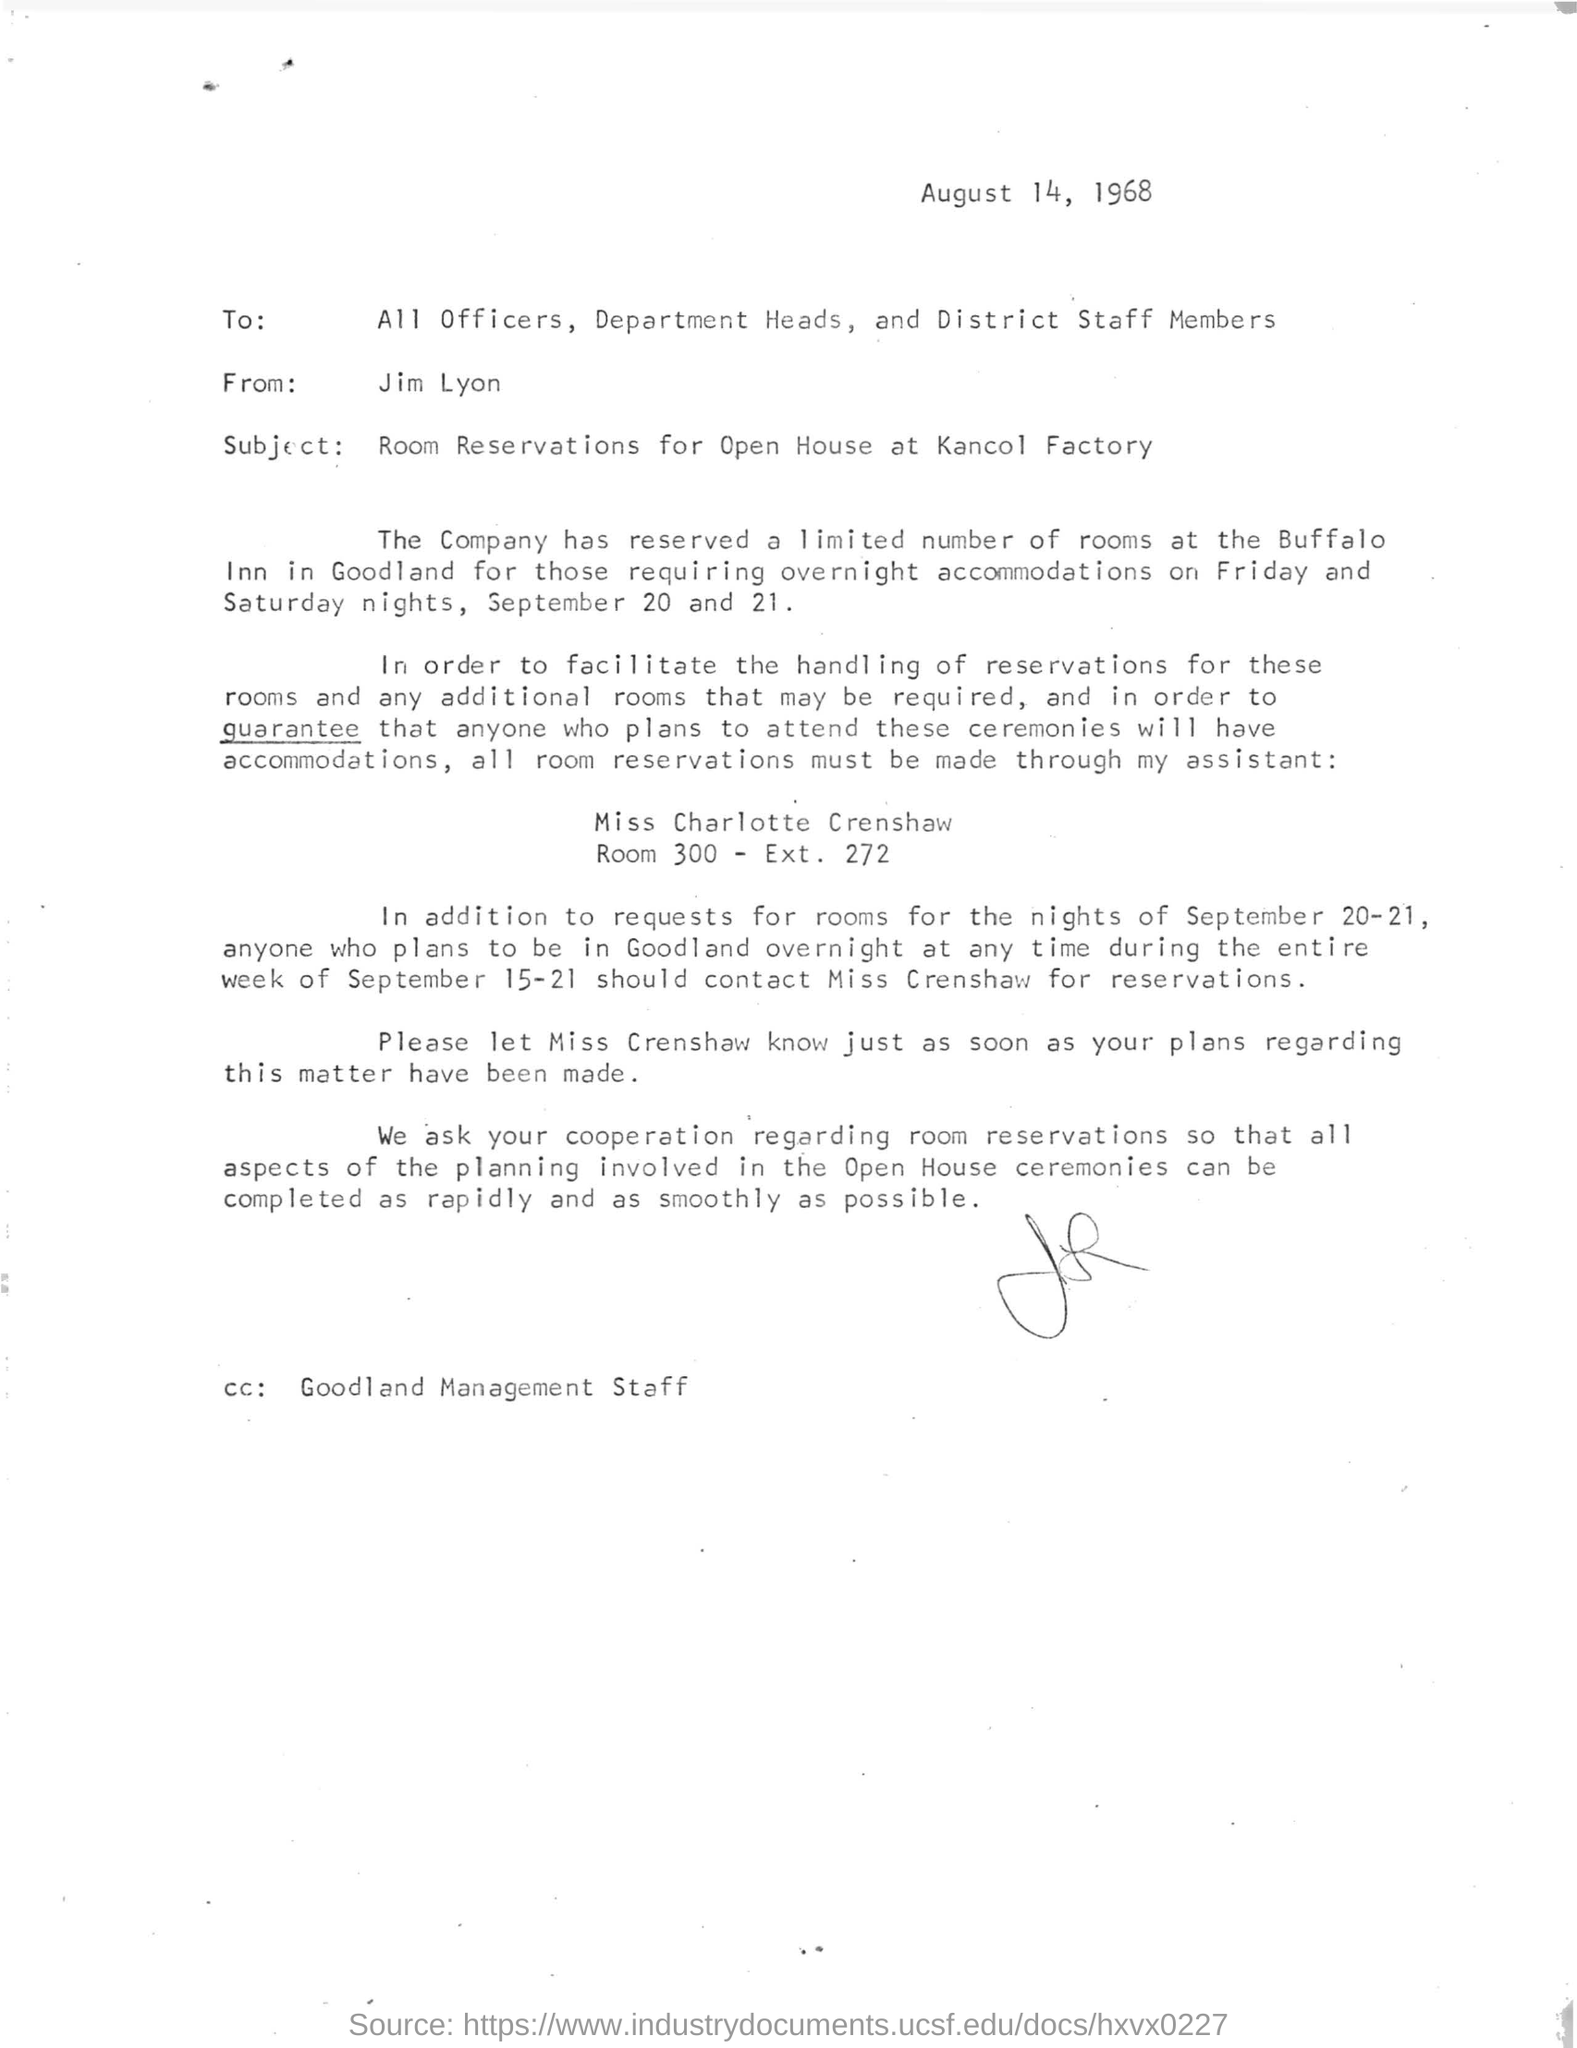When is the letter dated on?
Your answer should be compact. August 14, 1968. 